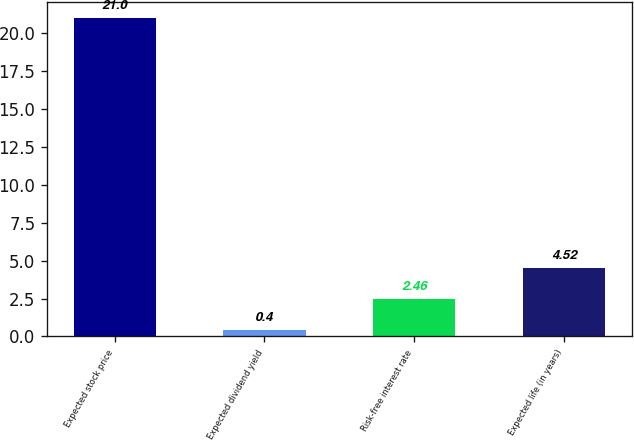<chart> <loc_0><loc_0><loc_500><loc_500><bar_chart><fcel>Expected stock price<fcel>Expected dividend yield<fcel>Risk-free interest rate<fcel>Expected life (in years)<nl><fcel>21<fcel>0.4<fcel>2.46<fcel>4.52<nl></chart> 